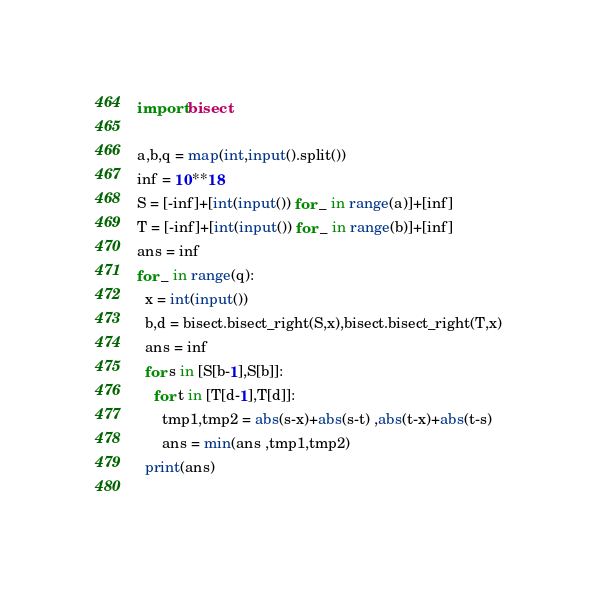Convert code to text. <code><loc_0><loc_0><loc_500><loc_500><_Python_>import bisect
 
a,b,q = map(int,input().split())
inf = 10**18
S = [-inf]+[int(input()) for _ in range(a)]+[inf]
T = [-inf]+[int(input()) for _ in range(b)]+[inf]
ans = inf
for _ in range(q):
  x = int(input())
  b,d = bisect.bisect_right(S,x),bisect.bisect_right(T,x)
  ans = inf
  for s in [S[b-1],S[b]]:
    for t in [T[d-1],T[d]]:
      tmp1,tmp2 = abs(s-x)+abs(s-t) ,abs(t-x)+abs(t-s)
      ans = min(ans ,tmp1,tmp2)
  print(ans)
      

</code> 